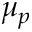Convert formula to latex. <formula><loc_0><loc_0><loc_500><loc_500>\mu _ { p }</formula> 